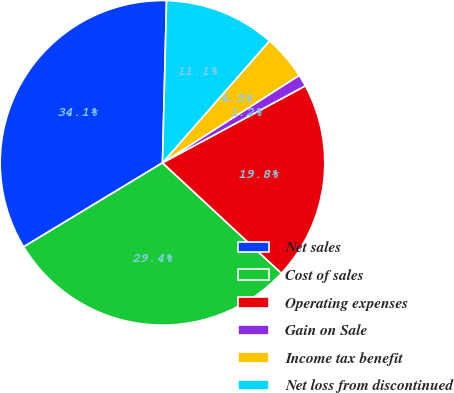Convert chart. <chart><loc_0><loc_0><loc_500><loc_500><pie_chart><fcel>Net sales<fcel>Cost of sales<fcel>Operating expenses<fcel>Gain on Sale<fcel>Income tax benefit<fcel>Net loss from discontinued<nl><fcel>34.06%<fcel>29.43%<fcel>19.78%<fcel>1.19%<fcel>4.48%<fcel>11.06%<nl></chart> 